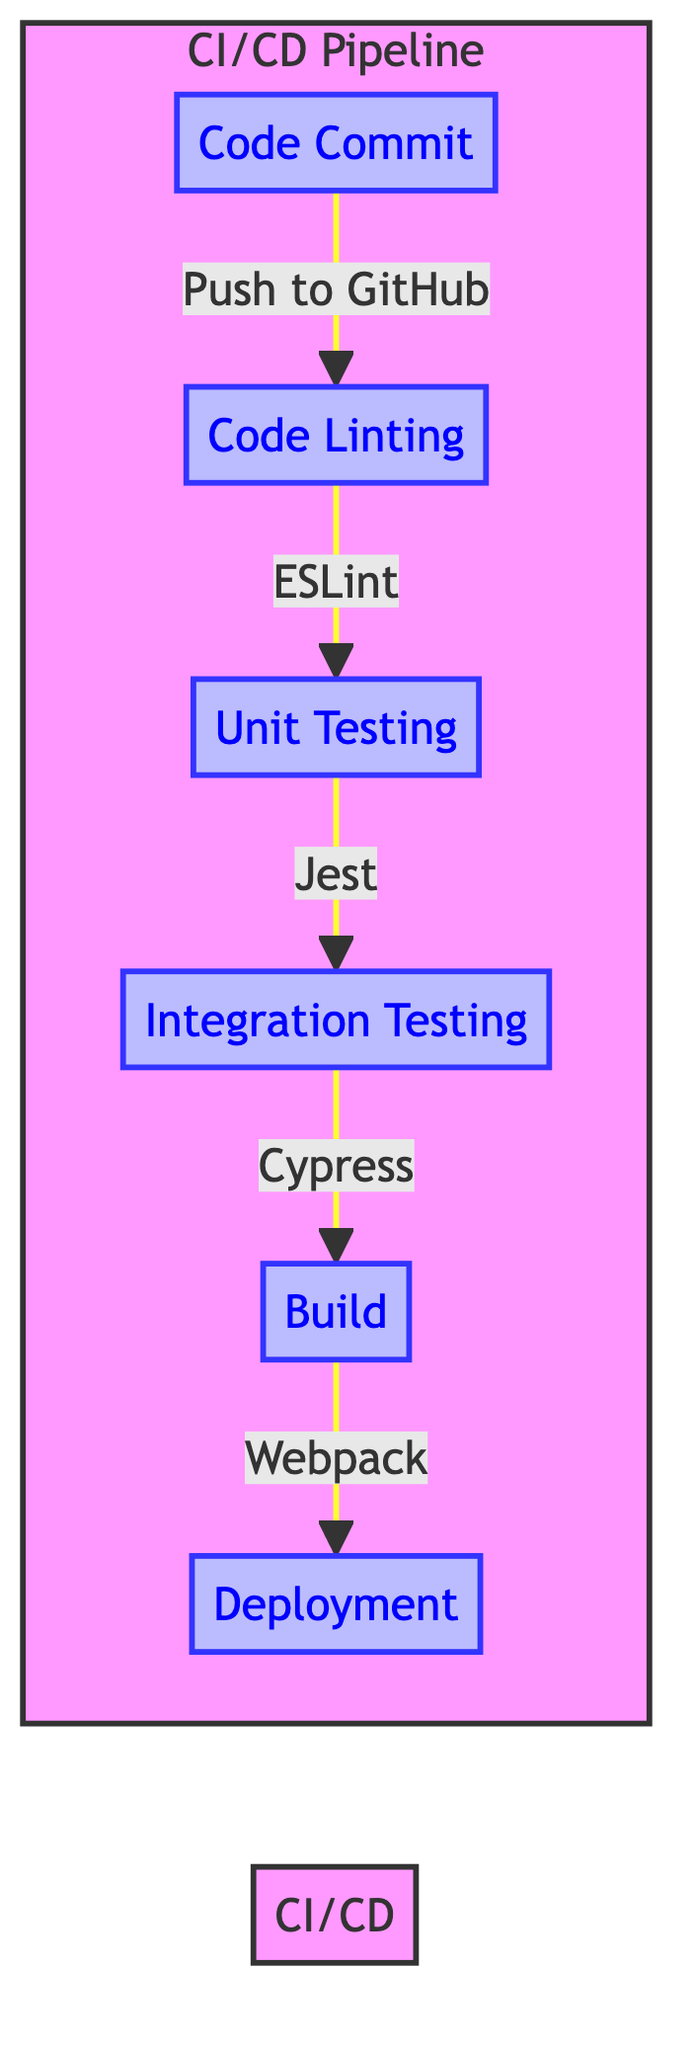What is the first stage in the CI/CD pipeline? The diagram indicates that the first stage in the CI/CD pipeline is labeled "Code Commit." This is the starting node from which all other processes flow.
Answer: Code Commit Which tool is used for code linting? The flowchart specifies that ESLint is the automated tool employed for the code linting stage. This is indicated by the arrow leading from code linting to Jest.
Answer: ESLint How many stages are there in the CI/CD pipeline? The diagram outlines a total of six stages from "Code Commit" to "Deployment." Each individual box denotes a distinct stage within the flowchart.
Answer: Six What comes after Unit Testing in the CI/CD pipeline? From the flowchart, the next stage after "Unit Testing" is labeled "Integration Testing," signified by the arrow that points from Unit Testing to Integration Testing.
Answer: Integration Testing Which stage does the arrow from "Build" point to? The arrow from the "Build" stage points to "Deployment," indicating that once the application is built, it proceeds to the deployment phase, as per the structure of the flowchart.
Answer: Deployment What is the final stage in this CI/CD process? The last stage in the CI/CD pipeline, denoted by the final node in the flowchart, is "Deployment," which signifies the completion of the pipeline process.
Answer: Deployment Which stage involves verifying that individual modules perform as expected? The diagram specifies that "Unit Testing" is the stage where individual modules are verified for their expected performance, according to the flow of the process.
Answer: Unit Testing What is the purpose of Cypress in the CI/CD pipeline? The flowchart highlights that Cypress is used for executing integration tests, which validate the collaborative functionality of different software components.
Answer: Integration Testing What are the first and last stages in the CI/CD pipeline? The first stage is "Code Commit," as indicated by the starting node, while the last stage is "Deployment," marked as the terminal step in the diagram.
Answer: Code Commit and Deployment 